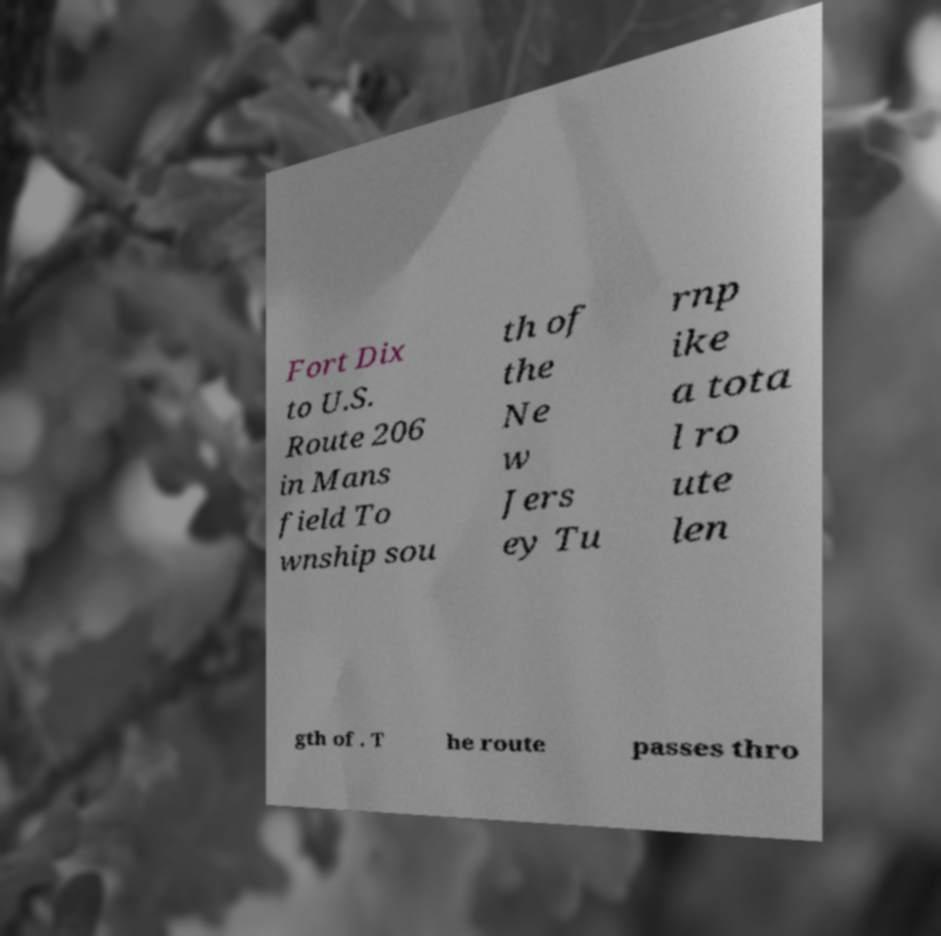There's text embedded in this image that I need extracted. Can you transcribe it verbatim? Fort Dix to U.S. Route 206 in Mans field To wnship sou th of the Ne w Jers ey Tu rnp ike a tota l ro ute len gth of . T he route passes thro 